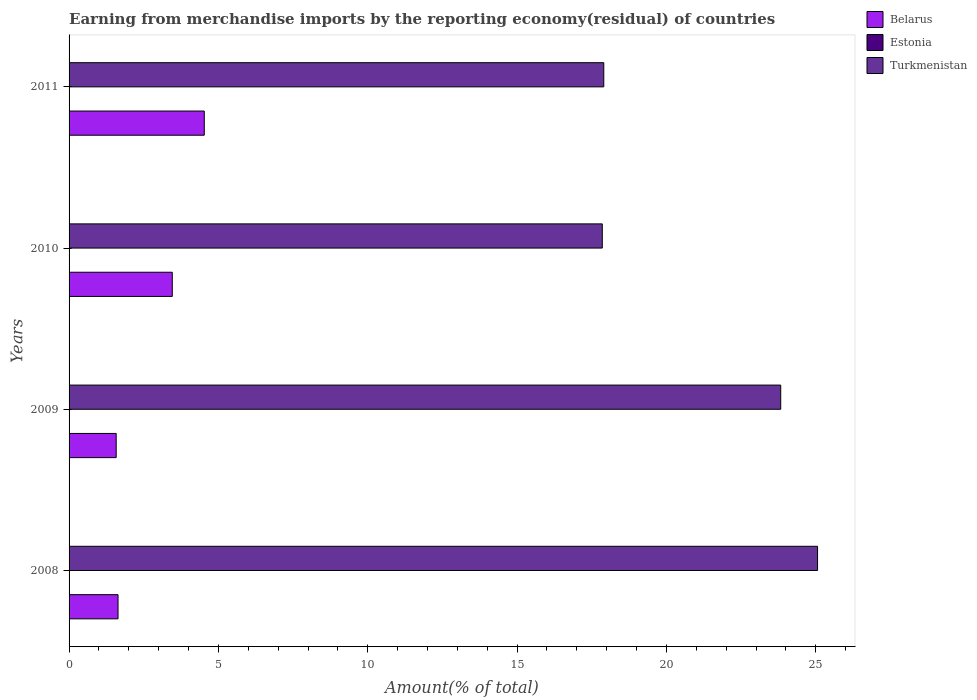Are the number of bars per tick equal to the number of legend labels?
Your answer should be compact. Yes. How many bars are there on the 2nd tick from the top?
Your answer should be compact. 3. What is the label of the 4th group of bars from the top?
Offer a very short reply. 2008. In how many cases, is the number of bars for a given year not equal to the number of legend labels?
Provide a short and direct response. 0. What is the percentage of amount earned from merchandise imports in Estonia in 2011?
Your answer should be very brief. 0. Across all years, what is the maximum percentage of amount earned from merchandise imports in Estonia?
Make the answer very short. 0. Across all years, what is the minimum percentage of amount earned from merchandise imports in Estonia?
Your answer should be very brief. 2.66567306426196e-5. In which year was the percentage of amount earned from merchandise imports in Belarus maximum?
Keep it short and to the point. 2011. What is the total percentage of amount earned from merchandise imports in Belarus in the graph?
Provide a succinct answer. 11.2. What is the difference between the percentage of amount earned from merchandise imports in Turkmenistan in 2008 and that in 2011?
Your response must be concise. 7.16. What is the difference between the percentage of amount earned from merchandise imports in Turkmenistan in 2010 and the percentage of amount earned from merchandise imports in Belarus in 2009?
Your answer should be very brief. 16.28. What is the average percentage of amount earned from merchandise imports in Turkmenistan per year?
Keep it short and to the point. 21.16. In the year 2011, what is the difference between the percentage of amount earned from merchandise imports in Estonia and percentage of amount earned from merchandise imports in Belarus?
Make the answer very short. -4.53. In how many years, is the percentage of amount earned from merchandise imports in Estonia greater than 13 %?
Your response must be concise. 0. What is the ratio of the percentage of amount earned from merchandise imports in Turkmenistan in 2008 to that in 2009?
Offer a terse response. 1.05. Is the difference between the percentage of amount earned from merchandise imports in Estonia in 2009 and 2010 greater than the difference between the percentage of amount earned from merchandise imports in Belarus in 2009 and 2010?
Give a very brief answer. Yes. What is the difference between the highest and the second highest percentage of amount earned from merchandise imports in Belarus?
Your answer should be compact. 1.07. What is the difference between the highest and the lowest percentage of amount earned from merchandise imports in Belarus?
Your answer should be very brief. 2.95. Is the sum of the percentage of amount earned from merchandise imports in Turkmenistan in 2009 and 2010 greater than the maximum percentage of amount earned from merchandise imports in Estonia across all years?
Your response must be concise. Yes. What does the 3rd bar from the top in 2010 represents?
Ensure brevity in your answer.  Belarus. What does the 3rd bar from the bottom in 2010 represents?
Offer a very short reply. Turkmenistan. How many years are there in the graph?
Offer a terse response. 4. What is the difference between two consecutive major ticks on the X-axis?
Your response must be concise. 5. Are the values on the major ticks of X-axis written in scientific E-notation?
Your response must be concise. No. What is the title of the graph?
Offer a very short reply. Earning from merchandise imports by the reporting economy(residual) of countries. Does "Turkey" appear as one of the legend labels in the graph?
Your answer should be very brief. No. What is the label or title of the X-axis?
Make the answer very short. Amount(% of total). What is the label or title of the Y-axis?
Your response must be concise. Years. What is the Amount(% of total) of Belarus in 2008?
Provide a succinct answer. 1.64. What is the Amount(% of total) of Estonia in 2008?
Keep it short and to the point. 0. What is the Amount(% of total) in Turkmenistan in 2008?
Offer a terse response. 25.06. What is the Amount(% of total) of Belarus in 2009?
Your answer should be very brief. 1.58. What is the Amount(% of total) of Estonia in 2009?
Offer a terse response. 0. What is the Amount(% of total) of Turkmenistan in 2009?
Provide a succinct answer. 23.83. What is the Amount(% of total) in Belarus in 2010?
Your response must be concise. 3.46. What is the Amount(% of total) of Estonia in 2010?
Ensure brevity in your answer.  2.66567306426196e-5. What is the Amount(% of total) of Turkmenistan in 2010?
Offer a very short reply. 17.85. What is the Amount(% of total) in Belarus in 2011?
Your answer should be compact. 4.53. What is the Amount(% of total) in Estonia in 2011?
Offer a very short reply. 0. What is the Amount(% of total) in Turkmenistan in 2011?
Your response must be concise. 17.9. Across all years, what is the maximum Amount(% of total) in Belarus?
Give a very brief answer. 4.53. Across all years, what is the maximum Amount(% of total) in Estonia?
Your answer should be compact. 0. Across all years, what is the maximum Amount(% of total) of Turkmenistan?
Make the answer very short. 25.06. Across all years, what is the minimum Amount(% of total) of Belarus?
Keep it short and to the point. 1.58. Across all years, what is the minimum Amount(% of total) in Estonia?
Provide a short and direct response. 2.66567306426196e-5. Across all years, what is the minimum Amount(% of total) of Turkmenistan?
Make the answer very short. 17.85. What is the total Amount(% of total) in Belarus in the graph?
Offer a terse response. 11.2. What is the total Amount(% of total) in Estonia in the graph?
Your response must be concise. 0. What is the total Amount(% of total) in Turkmenistan in the graph?
Make the answer very short. 84.64. What is the difference between the Amount(% of total) in Belarus in 2008 and that in 2009?
Offer a very short reply. 0.06. What is the difference between the Amount(% of total) of Estonia in 2008 and that in 2009?
Offer a very short reply. 0. What is the difference between the Amount(% of total) in Turkmenistan in 2008 and that in 2009?
Offer a terse response. 1.23. What is the difference between the Amount(% of total) of Belarus in 2008 and that in 2010?
Keep it short and to the point. -1.82. What is the difference between the Amount(% of total) of Turkmenistan in 2008 and that in 2010?
Your answer should be compact. 7.21. What is the difference between the Amount(% of total) of Belarus in 2008 and that in 2011?
Ensure brevity in your answer.  -2.89. What is the difference between the Amount(% of total) in Estonia in 2008 and that in 2011?
Ensure brevity in your answer.  0. What is the difference between the Amount(% of total) in Turkmenistan in 2008 and that in 2011?
Your response must be concise. 7.16. What is the difference between the Amount(% of total) of Belarus in 2009 and that in 2010?
Make the answer very short. -1.88. What is the difference between the Amount(% of total) of Turkmenistan in 2009 and that in 2010?
Ensure brevity in your answer.  5.97. What is the difference between the Amount(% of total) of Belarus in 2009 and that in 2011?
Provide a succinct answer. -2.95. What is the difference between the Amount(% of total) of Estonia in 2009 and that in 2011?
Your answer should be compact. 0. What is the difference between the Amount(% of total) of Turkmenistan in 2009 and that in 2011?
Ensure brevity in your answer.  5.92. What is the difference between the Amount(% of total) of Belarus in 2010 and that in 2011?
Your answer should be very brief. -1.07. What is the difference between the Amount(% of total) of Estonia in 2010 and that in 2011?
Offer a very short reply. -0. What is the difference between the Amount(% of total) of Belarus in 2008 and the Amount(% of total) of Estonia in 2009?
Ensure brevity in your answer.  1.64. What is the difference between the Amount(% of total) in Belarus in 2008 and the Amount(% of total) in Turkmenistan in 2009?
Make the answer very short. -22.19. What is the difference between the Amount(% of total) in Estonia in 2008 and the Amount(% of total) in Turkmenistan in 2009?
Offer a very short reply. -23.83. What is the difference between the Amount(% of total) in Belarus in 2008 and the Amount(% of total) in Estonia in 2010?
Ensure brevity in your answer.  1.64. What is the difference between the Amount(% of total) in Belarus in 2008 and the Amount(% of total) in Turkmenistan in 2010?
Your response must be concise. -16.21. What is the difference between the Amount(% of total) of Estonia in 2008 and the Amount(% of total) of Turkmenistan in 2010?
Your response must be concise. -17.85. What is the difference between the Amount(% of total) of Belarus in 2008 and the Amount(% of total) of Estonia in 2011?
Offer a very short reply. 1.64. What is the difference between the Amount(% of total) in Belarus in 2008 and the Amount(% of total) in Turkmenistan in 2011?
Make the answer very short. -16.26. What is the difference between the Amount(% of total) in Estonia in 2008 and the Amount(% of total) in Turkmenistan in 2011?
Provide a succinct answer. -17.9. What is the difference between the Amount(% of total) in Belarus in 2009 and the Amount(% of total) in Estonia in 2010?
Your response must be concise. 1.58. What is the difference between the Amount(% of total) in Belarus in 2009 and the Amount(% of total) in Turkmenistan in 2010?
Provide a short and direct response. -16.28. What is the difference between the Amount(% of total) in Estonia in 2009 and the Amount(% of total) in Turkmenistan in 2010?
Make the answer very short. -17.85. What is the difference between the Amount(% of total) in Belarus in 2009 and the Amount(% of total) in Estonia in 2011?
Make the answer very short. 1.58. What is the difference between the Amount(% of total) in Belarus in 2009 and the Amount(% of total) in Turkmenistan in 2011?
Keep it short and to the point. -16.33. What is the difference between the Amount(% of total) in Estonia in 2009 and the Amount(% of total) in Turkmenistan in 2011?
Provide a succinct answer. -17.9. What is the difference between the Amount(% of total) in Belarus in 2010 and the Amount(% of total) in Estonia in 2011?
Offer a very short reply. 3.46. What is the difference between the Amount(% of total) of Belarus in 2010 and the Amount(% of total) of Turkmenistan in 2011?
Offer a very short reply. -14.45. What is the difference between the Amount(% of total) of Estonia in 2010 and the Amount(% of total) of Turkmenistan in 2011?
Provide a succinct answer. -17.9. What is the average Amount(% of total) of Belarus per year?
Keep it short and to the point. 2.8. What is the average Amount(% of total) of Estonia per year?
Give a very brief answer. 0. What is the average Amount(% of total) of Turkmenistan per year?
Keep it short and to the point. 21.16. In the year 2008, what is the difference between the Amount(% of total) in Belarus and Amount(% of total) in Estonia?
Ensure brevity in your answer.  1.64. In the year 2008, what is the difference between the Amount(% of total) in Belarus and Amount(% of total) in Turkmenistan?
Provide a short and direct response. -23.42. In the year 2008, what is the difference between the Amount(% of total) of Estonia and Amount(% of total) of Turkmenistan?
Ensure brevity in your answer.  -25.06. In the year 2009, what is the difference between the Amount(% of total) in Belarus and Amount(% of total) in Estonia?
Your answer should be very brief. 1.58. In the year 2009, what is the difference between the Amount(% of total) of Belarus and Amount(% of total) of Turkmenistan?
Keep it short and to the point. -22.25. In the year 2009, what is the difference between the Amount(% of total) in Estonia and Amount(% of total) in Turkmenistan?
Offer a terse response. -23.83. In the year 2010, what is the difference between the Amount(% of total) of Belarus and Amount(% of total) of Estonia?
Your answer should be compact. 3.46. In the year 2010, what is the difference between the Amount(% of total) in Belarus and Amount(% of total) in Turkmenistan?
Your answer should be very brief. -14.4. In the year 2010, what is the difference between the Amount(% of total) in Estonia and Amount(% of total) in Turkmenistan?
Offer a terse response. -17.85. In the year 2011, what is the difference between the Amount(% of total) of Belarus and Amount(% of total) of Estonia?
Ensure brevity in your answer.  4.53. In the year 2011, what is the difference between the Amount(% of total) in Belarus and Amount(% of total) in Turkmenistan?
Give a very brief answer. -13.38. In the year 2011, what is the difference between the Amount(% of total) of Estonia and Amount(% of total) of Turkmenistan?
Give a very brief answer. -17.9. What is the ratio of the Amount(% of total) in Belarus in 2008 to that in 2009?
Provide a succinct answer. 1.04. What is the ratio of the Amount(% of total) in Estonia in 2008 to that in 2009?
Your answer should be compact. 2.27. What is the ratio of the Amount(% of total) of Turkmenistan in 2008 to that in 2009?
Provide a short and direct response. 1.05. What is the ratio of the Amount(% of total) in Belarus in 2008 to that in 2010?
Keep it short and to the point. 0.47. What is the ratio of the Amount(% of total) in Estonia in 2008 to that in 2010?
Your answer should be very brief. 18.71. What is the ratio of the Amount(% of total) in Turkmenistan in 2008 to that in 2010?
Your answer should be very brief. 1.4. What is the ratio of the Amount(% of total) of Belarus in 2008 to that in 2011?
Your response must be concise. 0.36. What is the ratio of the Amount(% of total) in Estonia in 2008 to that in 2011?
Make the answer very short. 2.93. What is the ratio of the Amount(% of total) in Turkmenistan in 2008 to that in 2011?
Give a very brief answer. 1.4. What is the ratio of the Amount(% of total) in Belarus in 2009 to that in 2010?
Your answer should be very brief. 0.46. What is the ratio of the Amount(% of total) of Estonia in 2009 to that in 2010?
Offer a terse response. 8.24. What is the ratio of the Amount(% of total) in Turkmenistan in 2009 to that in 2010?
Your answer should be compact. 1.33. What is the ratio of the Amount(% of total) in Belarus in 2009 to that in 2011?
Make the answer very short. 0.35. What is the ratio of the Amount(% of total) in Estonia in 2009 to that in 2011?
Keep it short and to the point. 1.29. What is the ratio of the Amount(% of total) of Turkmenistan in 2009 to that in 2011?
Offer a very short reply. 1.33. What is the ratio of the Amount(% of total) of Belarus in 2010 to that in 2011?
Offer a terse response. 0.76. What is the ratio of the Amount(% of total) of Estonia in 2010 to that in 2011?
Make the answer very short. 0.16. What is the ratio of the Amount(% of total) in Turkmenistan in 2010 to that in 2011?
Keep it short and to the point. 1. What is the difference between the highest and the second highest Amount(% of total) of Belarus?
Your answer should be very brief. 1.07. What is the difference between the highest and the second highest Amount(% of total) of Turkmenistan?
Ensure brevity in your answer.  1.23. What is the difference between the highest and the lowest Amount(% of total) in Belarus?
Provide a short and direct response. 2.95. What is the difference between the highest and the lowest Amount(% of total) in Turkmenistan?
Make the answer very short. 7.21. 